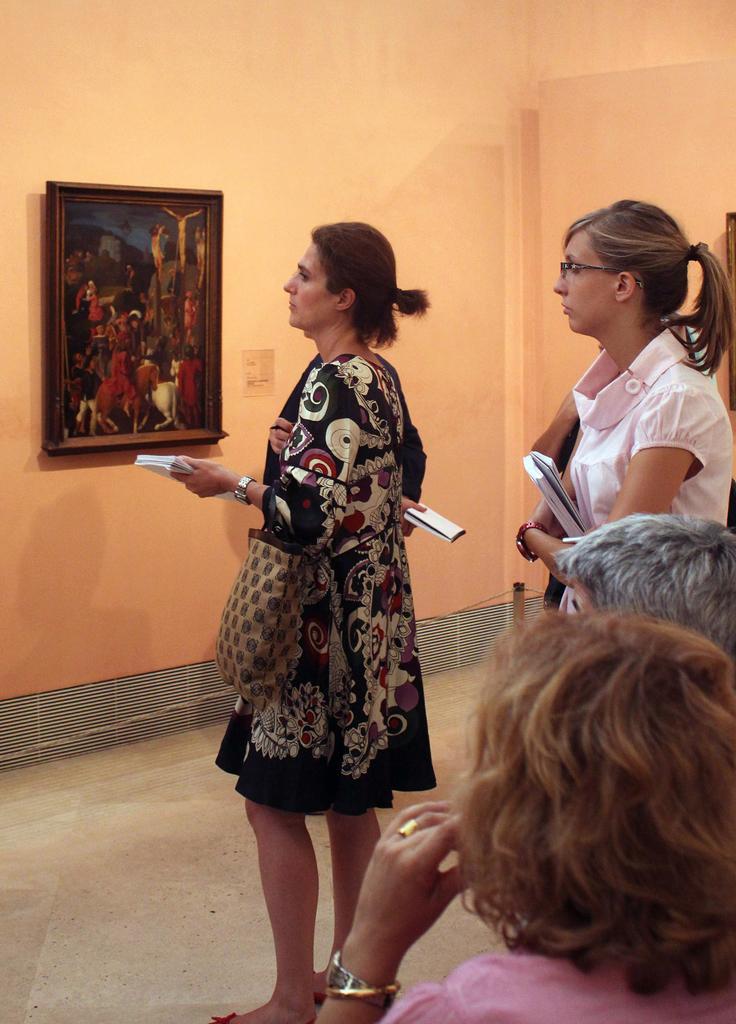Could you give a brief overview of what you see in this image? In this image I can see few people and two people are holding the bag and books. In front I can see the frame is attached to the cream wall. 